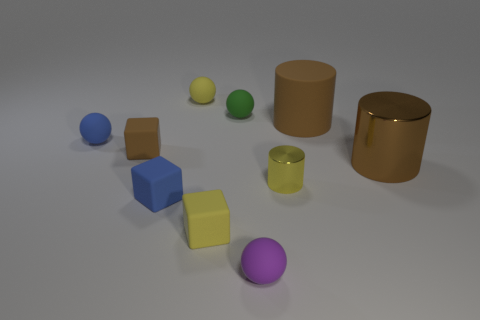Subtract all balls. How many objects are left? 6 Add 3 small blue matte cubes. How many small blue matte cubes exist? 4 Subtract 0 gray blocks. How many objects are left? 10 Subtract all brown shiny cylinders. Subtract all green rubber spheres. How many objects are left? 8 Add 7 blue matte objects. How many blue matte objects are left? 9 